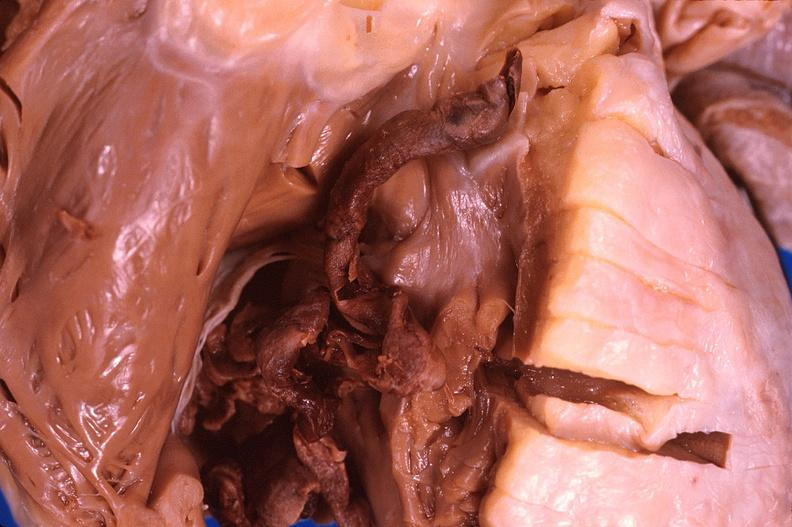s cardiovascular present?
Answer the question using a single word or phrase. Yes 